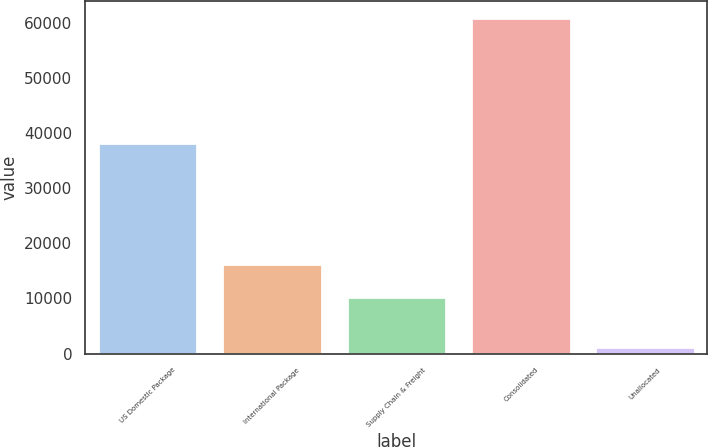<chart> <loc_0><loc_0><loc_500><loc_500><bar_chart><fcel>US Domestic Package<fcel>International Package<fcel>Supply Chain & Freight<fcel>Consolidated<fcel>Unallocated<nl><fcel>38301<fcel>16226.9<fcel>10255<fcel>60906<fcel>1187<nl></chart> 